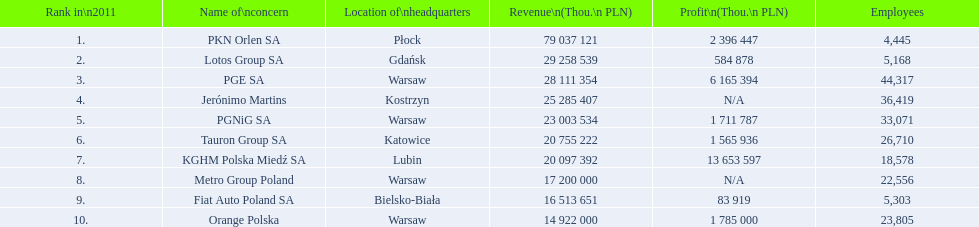What companies are listed? PKN Orlen SA, Lotos Group SA, PGE SA, Jerónimo Martins, PGNiG SA, Tauron Group SA, KGHM Polska Miedź SA, Metro Group Poland, Fiat Auto Poland SA, Orange Polska. What are the company's revenues? 79 037 121, 29 258 539, 28 111 354, 25 285 407, 23 003 534, 20 755 222, 20 097 392, 17 200 000, 16 513 651, 14 922 000. Which company has the greatest revenue? PKN Orlen SA. What is the count of employees working for pkn orlen sa in poland? 4,445. What count of employees work for lotos group sa? 5,168. How many individuals work for pgnig sa? 33,071. Can you provide the names of all the concerns? PKN Orlen SA, Lotos Group SA, PGE SA, Jerónimo Martins, PGNiG SA, Tauron Group SA, KGHM Polska Miedź SA, Metro Group Poland, Fiat Auto Poland SA, Orange Polska. How many workers are there in pgnig sa? 33,071. 